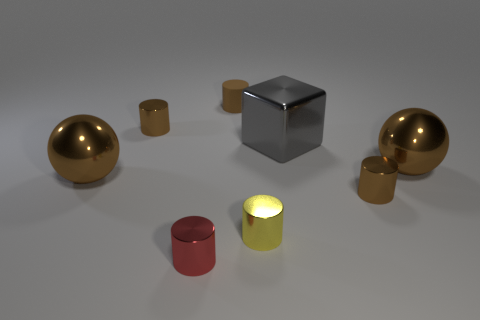How does the lighting in the scene affect the appearance of the metallic objects? The lighting creates a soft glow on the surfaces of the metallic objects, enhancing their sheen and giving them a realistically reflective quality. It seems to be coming from above, as indicated by the soft shadows under the objects, which adds depth to the scene. 